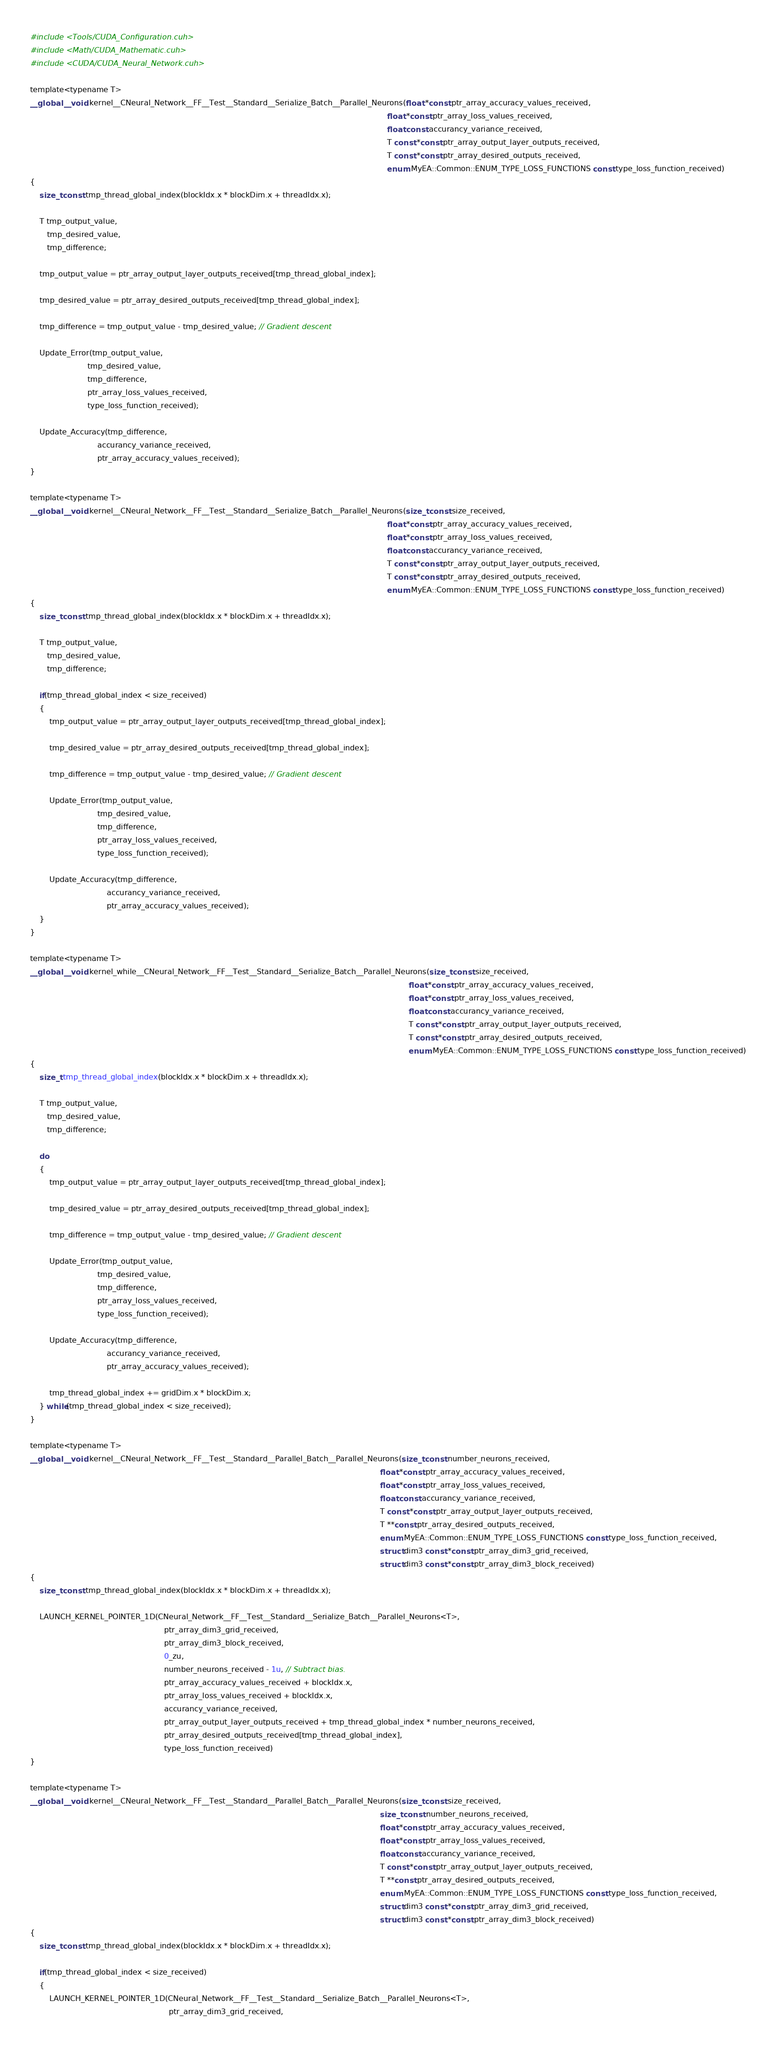<code> <loc_0><loc_0><loc_500><loc_500><_Cuda_>#include <Tools/CUDA_Configuration.cuh>
#include <Math/CUDA_Mathematic.cuh>
#include <CUDA/CUDA_Neural_Network.cuh>

template<typename T>
__global__ void kernel__CNeural_Network__FF__Test__Standard__Serialize_Batch__Parallel_Neurons(float *const ptr_array_accuracy_values_received,
                                                                                                                                                     float *const ptr_array_loss_values_received,
                                                                                                                                                     float const accurancy_variance_received,
                                                                                                                                                     T const *const ptr_array_output_layer_outputs_received,
                                                                                                                                                     T const *const ptr_array_desired_outputs_received,
                                                                                                                                                     enum MyEA::Common::ENUM_TYPE_LOSS_FUNCTIONS const type_loss_function_received)
{
    size_t const tmp_thread_global_index(blockIdx.x * blockDim.x + threadIdx.x);
    
    T tmp_output_value,
       tmp_desired_value,
       tmp_difference;
    
    tmp_output_value = ptr_array_output_layer_outputs_received[tmp_thread_global_index];

    tmp_desired_value = ptr_array_desired_outputs_received[tmp_thread_global_index];

    tmp_difference = tmp_output_value - tmp_desired_value; // Gradient descent
    
    Update_Error(tmp_output_value,
                        tmp_desired_value,
                        tmp_difference,
                        ptr_array_loss_values_received,
                        type_loss_function_received);
    
    Update_Accuracy(tmp_difference,
                            accurancy_variance_received,
                            ptr_array_accuracy_values_received);
}

template<typename T>
__global__ void kernel__CNeural_Network__FF__Test__Standard__Serialize_Batch__Parallel_Neurons(size_t const size_received,
                                                                                                                                                     float *const ptr_array_accuracy_values_received,
                                                                                                                                                     float *const ptr_array_loss_values_received,
                                                                                                                                                     float const accurancy_variance_received,
                                                                                                                                                     T const *const ptr_array_output_layer_outputs_received,
                                                                                                                                                     T const *const ptr_array_desired_outputs_received,
                                                                                                                                                     enum MyEA::Common::ENUM_TYPE_LOSS_FUNCTIONS const type_loss_function_received)
{
    size_t const tmp_thread_global_index(blockIdx.x * blockDim.x + threadIdx.x);
    
    T tmp_output_value,
       tmp_desired_value,
       tmp_difference;
    
    if(tmp_thread_global_index < size_received)
    {
        tmp_output_value = ptr_array_output_layer_outputs_received[tmp_thread_global_index];

        tmp_desired_value = ptr_array_desired_outputs_received[tmp_thread_global_index];

        tmp_difference = tmp_output_value - tmp_desired_value; // Gradient descent
        
        Update_Error(tmp_output_value,
                            tmp_desired_value,
                            tmp_difference,
                            ptr_array_loss_values_received,
                            type_loss_function_received);
        
        Update_Accuracy(tmp_difference,
                                accurancy_variance_received,
                                ptr_array_accuracy_values_received);
    }
}

template<typename T>
__global__ void kernel_while__CNeural_Network__FF__Test__Standard__Serialize_Batch__Parallel_Neurons(size_t const size_received,
                                                                                                                                                              float *const ptr_array_accuracy_values_received,
                                                                                                                                                              float *const ptr_array_loss_values_received,
                                                                                                                                                              float const accurancy_variance_received,
                                                                                                                                                              T const *const ptr_array_output_layer_outputs_received,
                                                                                                                                                              T const *const ptr_array_desired_outputs_received,
                                                                                                                                                              enum MyEA::Common::ENUM_TYPE_LOSS_FUNCTIONS const type_loss_function_received)
{
    size_t tmp_thread_global_index(blockIdx.x * blockDim.x + threadIdx.x);
    
    T tmp_output_value,
       tmp_desired_value,
       tmp_difference;
    
    do
    {
        tmp_output_value = ptr_array_output_layer_outputs_received[tmp_thread_global_index];

        tmp_desired_value = ptr_array_desired_outputs_received[tmp_thread_global_index];

        tmp_difference = tmp_output_value - tmp_desired_value; // Gradient descent
        
        Update_Error(tmp_output_value,
                            tmp_desired_value,
                            tmp_difference,
                            ptr_array_loss_values_received,
                            type_loss_function_received);
        
        Update_Accuracy(tmp_difference,
                                accurancy_variance_received,
                                ptr_array_accuracy_values_received);

        tmp_thread_global_index += gridDim.x * blockDim.x;
    } while(tmp_thread_global_index < size_received);
}

template<typename T>
__global__ void kernel__CNeural_Network__FF__Test__Standard__Parallel_Batch__Parallel_Neurons(size_t const number_neurons_received,
                                                                                                                                                  float *const ptr_array_accuracy_values_received,
                                                                                                                                                  float *const ptr_array_loss_values_received,
                                                                                                                                                  float const accurancy_variance_received,
                                                                                                                                                  T const *const ptr_array_output_layer_outputs_received,
                                                                                                                                                  T **const ptr_array_desired_outputs_received,
                                                                                                                                                  enum MyEA::Common::ENUM_TYPE_LOSS_FUNCTIONS const type_loss_function_received,
                                                                                                                                                  struct dim3 const *const ptr_array_dim3_grid_received,
                                                                                                                                                  struct dim3 const *const ptr_array_dim3_block_received)
{
    size_t const tmp_thread_global_index(blockIdx.x * blockDim.x + threadIdx.x);
    
    LAUNCH_KERNEL_POINTER_1D(CNeural_Network__FF__Test__Standard__Serialize_Batch__Parallel_Neurons<T>,
                                                        ptr_array_dim3_grid_received,
                                                        ptr_array_dim3_block_received,
                                                        0_zu,
                                                        number_neurons_received - 1u, // Subtract bias.
                                                        ptr_array_accuracy_values_received + blockIdx.x,
                                                        ptr_array_loss_values_received + blockIdx.x,
                                                        accurancy_variance_received,
                                                        ptr_array_output_layer_outputs_received + tmp_thread_global_index * number_neurons_received,
                                                        ptr_array_desired_outputs_received[tmp_thread_global_index],
                                                        type_loss_function_received)
}

template<typename T>
__global__ void kernel__CNeural_Network__FF__Test__Standard__Parallel_Batch__Parallel_Neurons(size_t const size_received,
                                                                                                                                                  size_t const number_neurons_received,
                                                                                                                                                  float *const ptr_array_accuracy_values_received,
                                                                                                                                                  float *const ptr_array_loss_values_received,
                                                                                                                                                  float const accurancy_variance_received,
                                                                                                                                                  T const *const ptr_array_output_layer_outputs_received,
                                                                                                                                                  T **const ptr_array_desired_outputs_received,
                                                                                                                                                  enum MyEA::Common::ENUM_TYPE_LOSS_FUNCTIONS const type_loss_function_received,
                                                                                                                                                  struct dim3 const *const ptr_array_dim3_grid_received,
                                                                                                                                                  struct dim3 const *const ptr_array_dim3_block_received)
{
    size_t const tmp_thread_global_index(blockIdx.x * blockDim.x + threadIdx.x);
    
    if(tmp_thread_global_index < size_received)
    {
        LAUNCH_KERNEL_POINTER_1D(CNeural_Network__FF__Test__Standard__Serialize_Batch__Parallel_Neurons<T>,
                                                          ptr_array_dim3_grid_received,</code> 